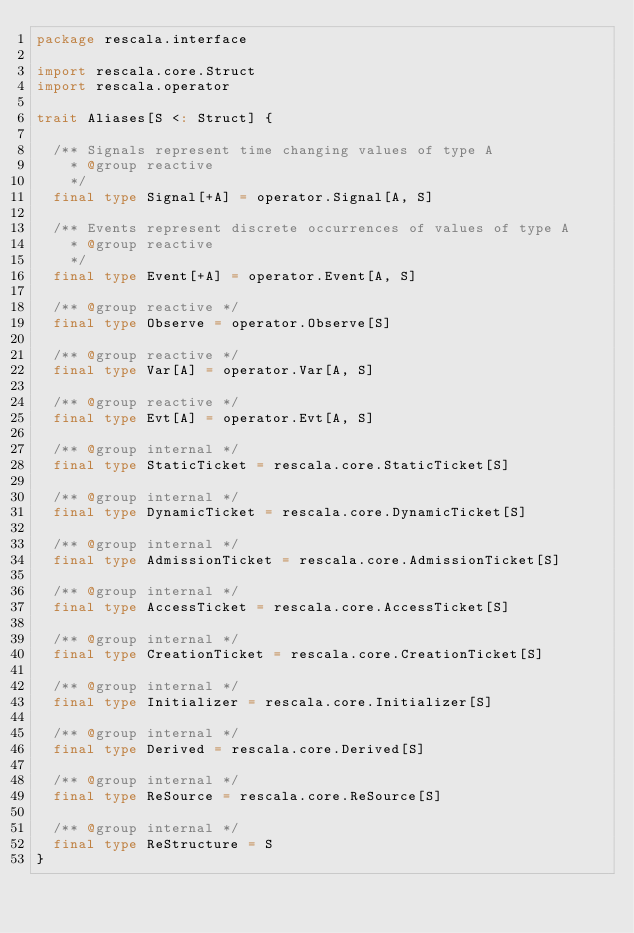<code> <loc_0><loc_0><loc_500><loc_500><_Scala_>package rescala.interface

import rescala.core.Struct
import rescala.operator

trait Aliases[S <: Struct] {

  /** Signals represent time changing values of type A
    * @group reactive
    */
  final type Signal[+A] = operator.Signal[A, S]

  /** Events represent discrete occurrences of values of type A
    * @group reactive
    */
  final type Event[+A] = operator.Event[A, S]

  /** @group reactive */
  final type Observe = operator.Observe[S]

  /** @group reactive */
  final type Var[A] = operator.Var[A, S]

  /** @group reactive */
  final type Evt[A] = operator.Evt[A, S]

  /** @group internal */
  final type StaticTicket = rescala.core.StaticTicket[S]

  /** @group internal */
  final type DynamicTicket = rescala.core.DynamicTicket[S]

  /** @group internal */
  final type AdmissionTicket = rescala.core.AdmissionTicket[S]

  /** @group internal */
  final type AccessTicket = rescala.core.AccessTicket[S]

  /** @group internal */
  final type CreationTicket = rescala.core.CreationTicket[S]

  /** @group internal */
  final type Initializer = rescala.core.Initializer[S]

  /** @group internal */
  final type Derived = rescala.core.Derived[S]

  /** @group internal */
  final type ReSource = rescala.core.ReSource[S]

  /** @group internal */
  final type ReStructure = S
}
</code> 